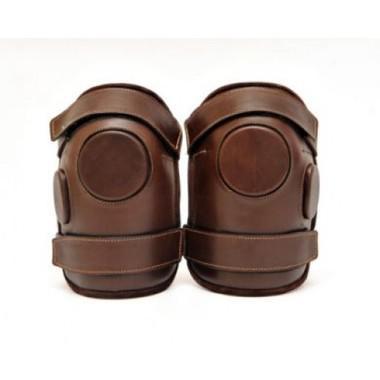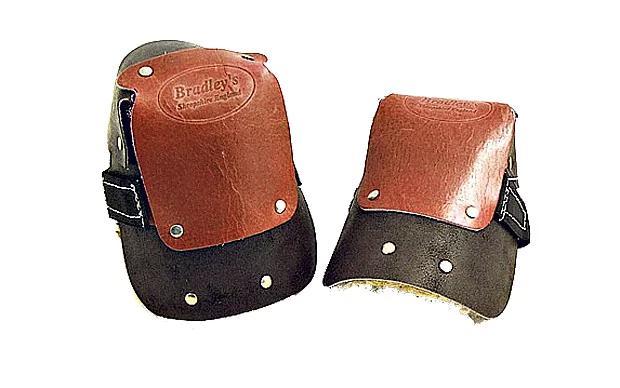The first image is the image on the left, the second image is the image on the right. Analyze the images presented: Is the assertion "The number of protective items are not an even number; it is an odd number." valid? Answer yes or no. No. 